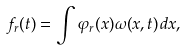<formula> <loc_0><loc_0><loc_500><loc_500>f _ { r } ( t ) = \int \varphi _ { r } ( x ) \omega ( x , t ) \, d x ,</formula> 